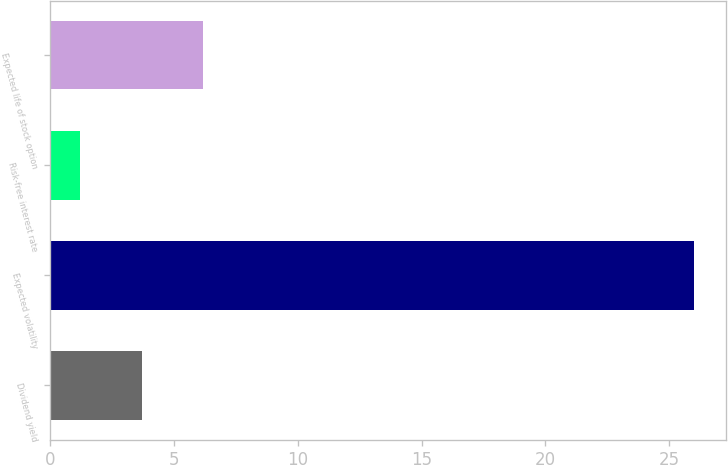<chart> <loc_0><loc_0><loc_500><loc_500><bar_chart><fcel>Dividend yield<fcel>Expected volatility<fcel>Risk-free interest rate<fcel>Expected life of stock option<nl><fcel>3.68<fcel>26<fcel>1.2<fcel>6.16<nl></chart> 